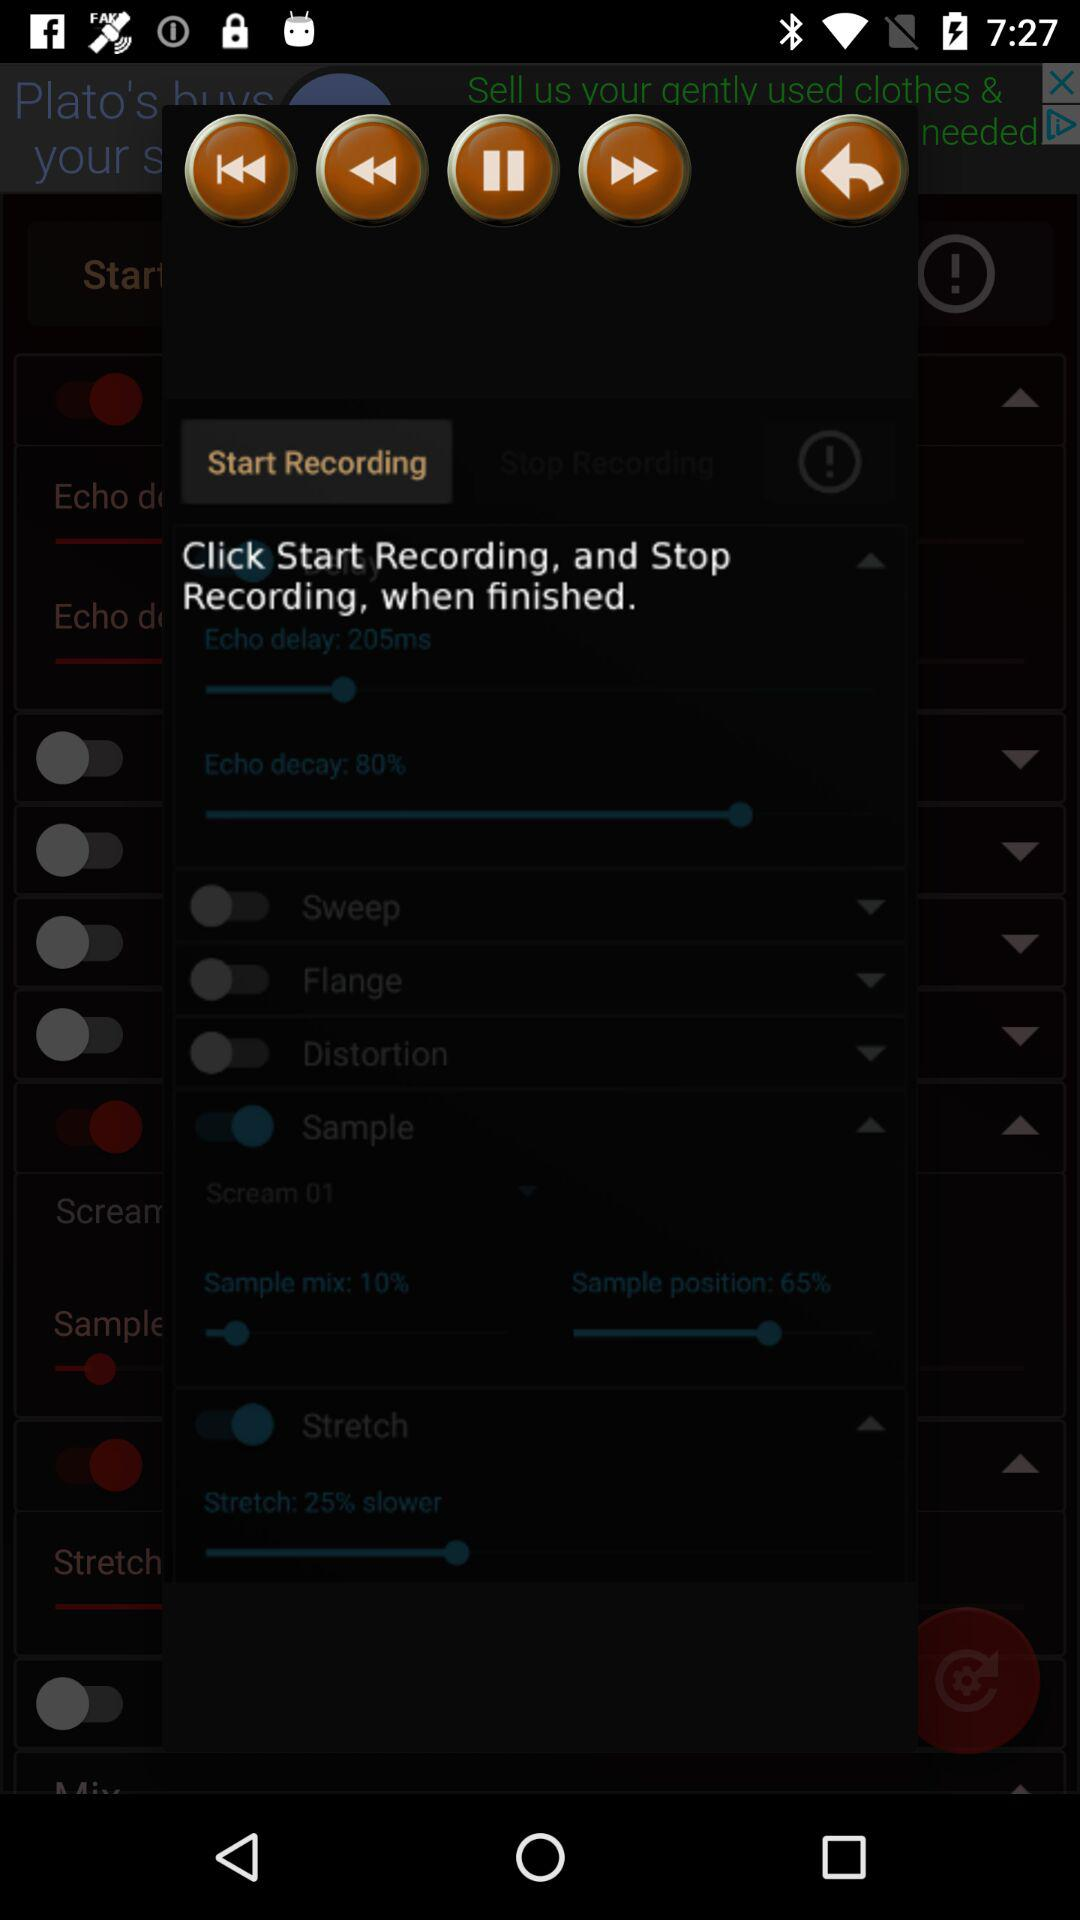What is the value of echo delay? The value is 250ms. 